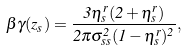Convert formula to latex. <formula><loc_0><loc_0><loc_500><loc_500>\beta \gamma ( z _ { s } ) = \frac { 3 \eta _ { s } ^ { r } ( 2 + \eta _ { s } ^ { r } ) } { 2 \pi \sigma _ { s s } ^ { 2 } ( 1 - \eta _ { s } ^ { r } ) ^ { 2 } } ,</formula> 